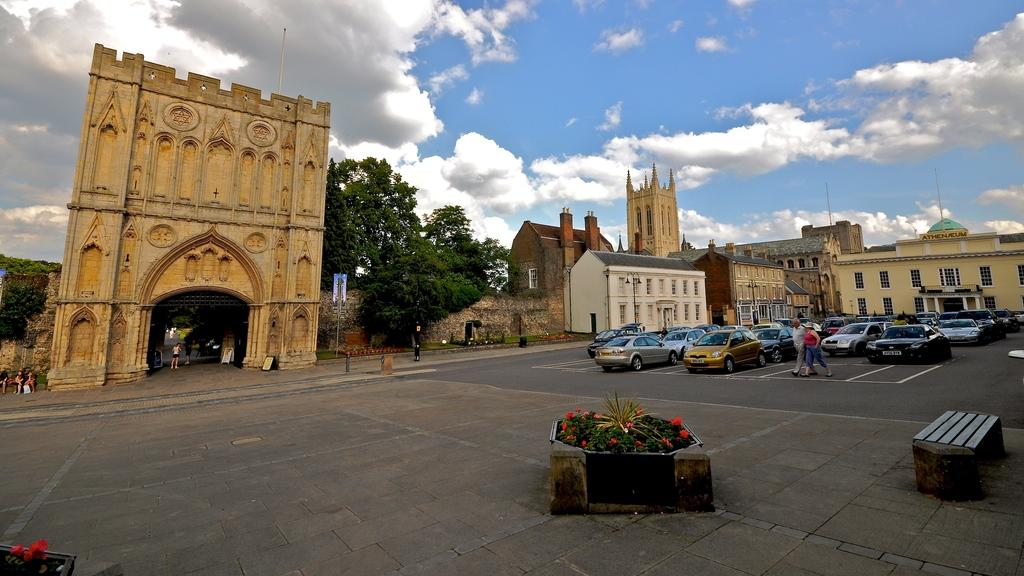What type of structures can be seen in the image? There are buildings in the image. What natural elements are present in the image? There are trees, plants, and flowers in the image. What mode of transportation can be seen in the image? There are vehicles in the image. Are there any living beings in the image? Yes, there are people in the image. What part of the natural environment is visible in the background of the image? The sky is visible in the background of the image. Can you tell me how many yams are being carried by the people in the image? There is no yam present in the image; it does not depict any yams being carried by people. What type of carriage is used by the people in the image? There is no carriage present in the image; it features vehicles and people but no carriages. 